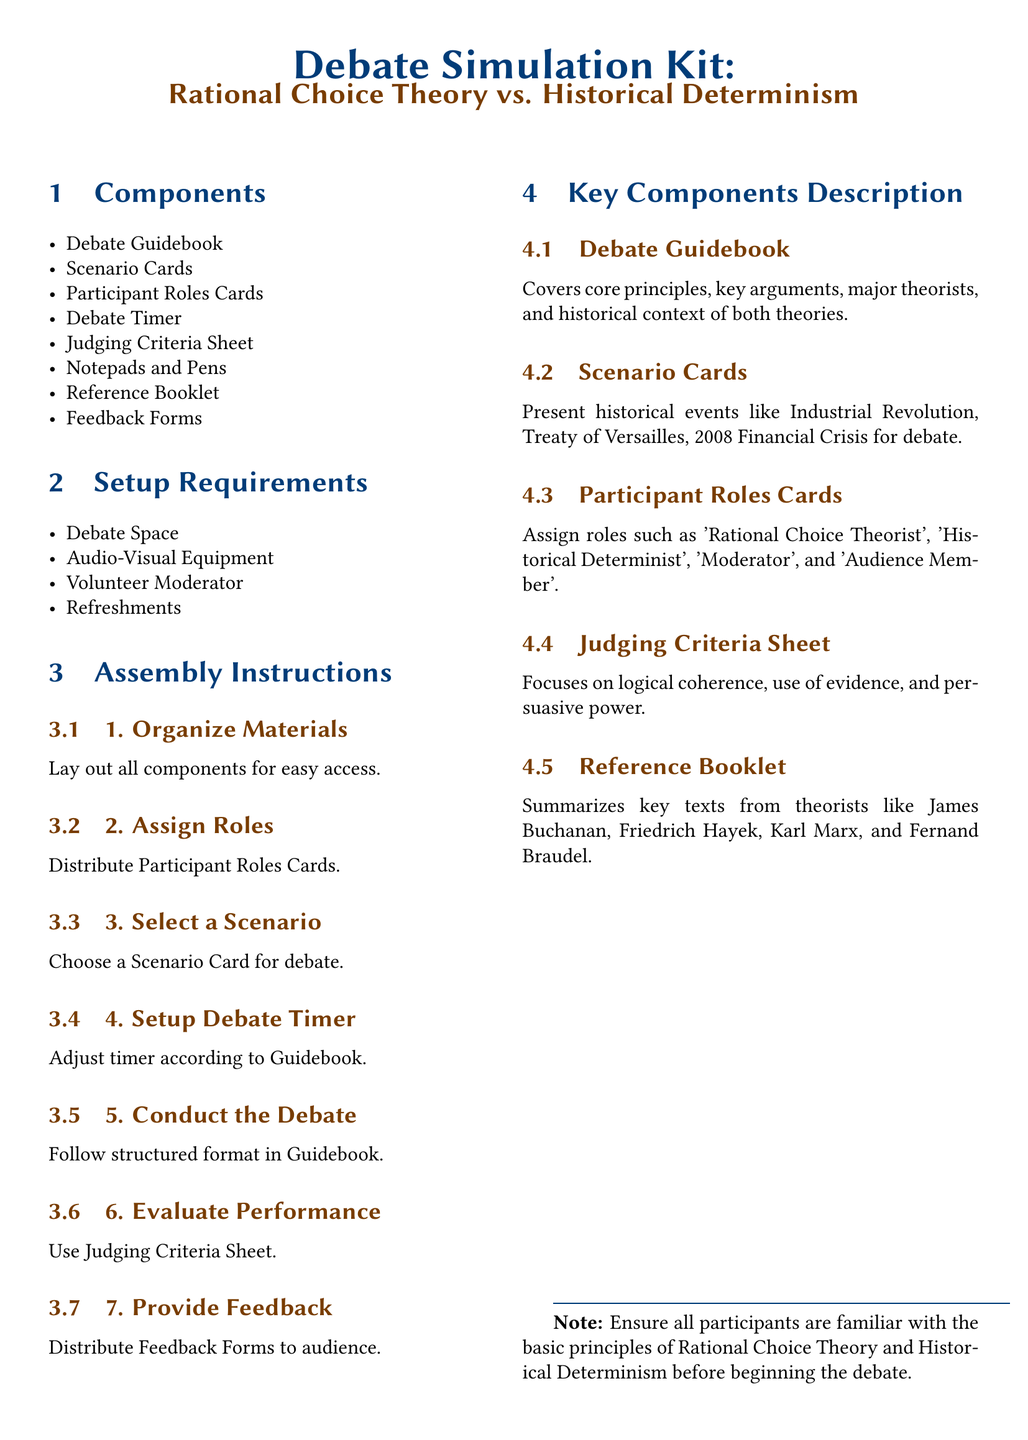what are the main components of the kit? The components listed in the document include various items essential for the debate simulation, such as a Debate Guidebook and Scenario Cards.
Answer: Debate Guidebook, Scenario Cards, Participant Roles Cards, Debate Timer, Judging Criteria Sheet, Notepads and Pens, Reference Booklet, Feedback Forms how many roles are assigned in the Participant Roles Cards? The document specifies the roles included in the Participant Roles Cards, such as 'Rational Choice Theorist' and 'Historical Determinist'.
Answer: 4 what is used to evaluate performance during the debate? The evaluation method mentioned in the document focuses on criteria outlined in a specific sheet provided to the judges.
Answer: Judging Criteria Sheet what is the first step in the assembly instructions? The initial assembly instruction details the organization of the kit's components for user convenience.
Answer: Organize Materials what historical events are presented in the Scenario Cards? The document lists examples of historical events that participants can debate about, including the Industrial Revolution and more.
Answer: Industrial Revolution, Treaty of Versailles, 2008 Financial Crisis what is the purpose of the Debate Timer? The timer's purpose is established in the document, highlighting its role in structuring the debate timing as per the guidelines.
Answer: Adjust timer according to Guidebook which theorists are referenced in the Reference Booklet? The document mentions several influential theorists as key references for participants in the debate, helping provide context.
Answer: James Buchanan, Friedrich Hayek, Karl Marx, and Fernand Braudel what type of space is required for the debate? The setup requirements emphasize the need for a space that accommodates the participants, ensuring the debate can proceed smoothly.
Answer: Debate Space 